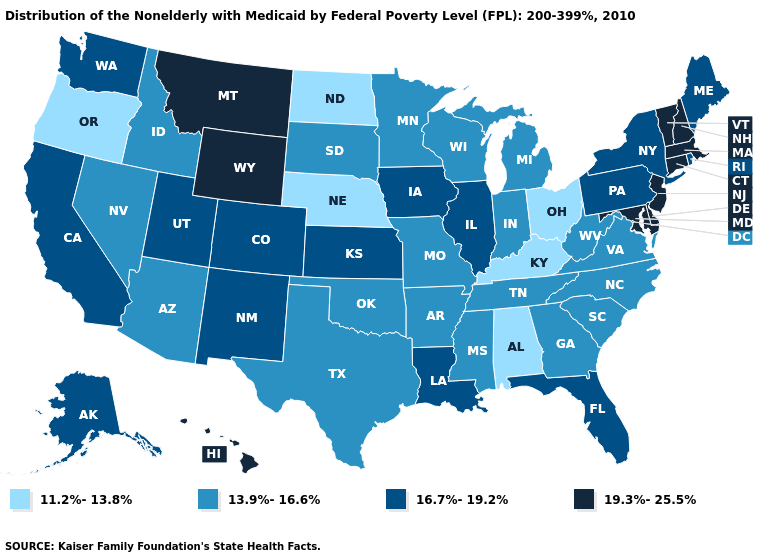Name the states that have a value in the range 13.9%-16.6%?
Short answer required. Arizona, Arkansas, Georgia, Idaho, Indiana, Michigan, Minnesota, Mississippi, Missouri, Nevada, North Carolina, Oklahoma, South Carolina, South Dakota, Tennessee, Texas, Virginia, West Virginia, Wisconsin. What is the value of Massachusetts?
Write a very short answer. 19.3%-25.5%. Among the states that border Vermont , which have the lowest value?
Write a very short answer. New York. What is the value of Arizona?
Give a very brief answer. 13.9%-16.6%. What is the lowest value in the South?
Quick response, please. 11.2%-13.8%. Name the states that have a value in the range 19.3%-25.5%?
Quick response, please. Connecticut, Delaware, Hawaii, Maryland, Massachusetts, Montana, New Hampshire, New Jersey, Vermont, Wyoming. What is the lowest value in states that border Texas?
Give a very brief answer. 13.9%-16.6%. What is the lowest value in states that border South Carolina?
Be succinct. 13.9%-16.6%. Name the states that have a value in the range 16.7%-19.2%?
Answer briefly. Alaska, California, Colorado, Florida, Illinois, Iowa, Kansas, Louisiana, Maine, New Mexico, New York, Pennsylvania, Rhode Island, Utah, Washington. What is the value of Mississippi?
Answer briefly. 13.9%-16.6%. What is the lowest value in states that border Arkansas?
Concise answer only. 13.9%-16.6%. Name the states that have a value in the range 16.7%-19.2%?
Short answer required. Alaska, California, Colorado, Florida, Illinois, Iowa, Kansas, Louisiana, Maine, New Mexico, New York, Pennsylvania, Rhode Island, Utah, Washington. What is the value of Indiana?
Keep it brief. 13.9%-16.6%. Name the states that have a value in the range 19.3%-25.5%?
Write a very short answer. Connecticut, Delaware, Hawaii, Maryland, Massachusetts, Montana, New Hampshire, New Jersey, Vermont, Wyoming. Among the states that border New York , does New Jersey have the highest value?
Answer briefly. Yes. 